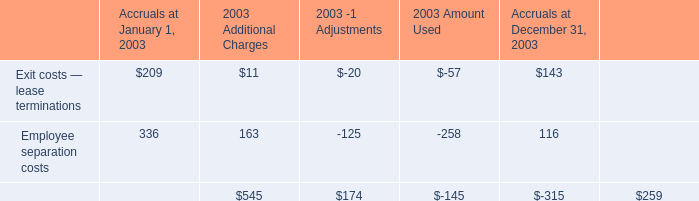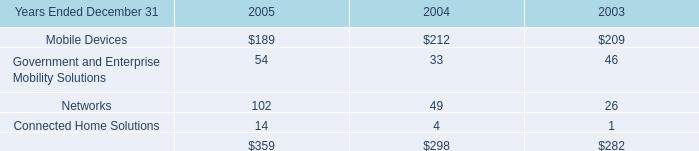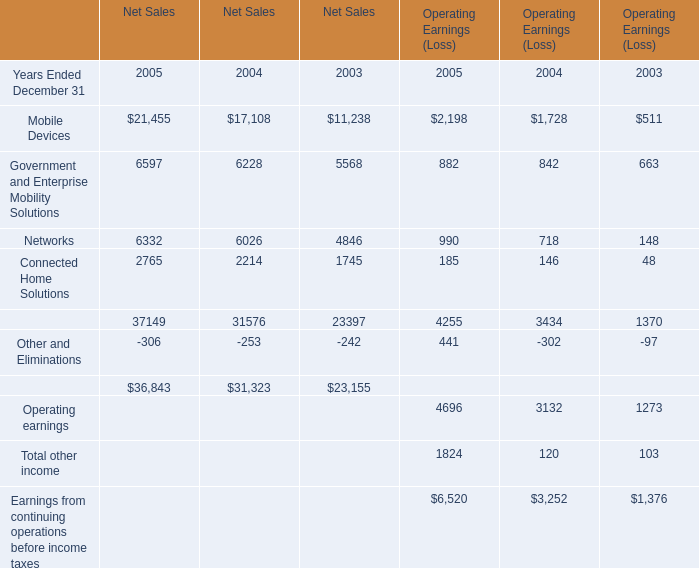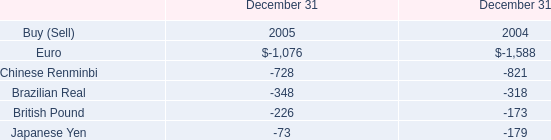What is the total amount of Government and Enterprise Mobility Solutions of Net Sales 2004, and Euro of December 31 2004 ? 
Computations: (6228.0 + 1588.0)
Answer: 7816.0. 